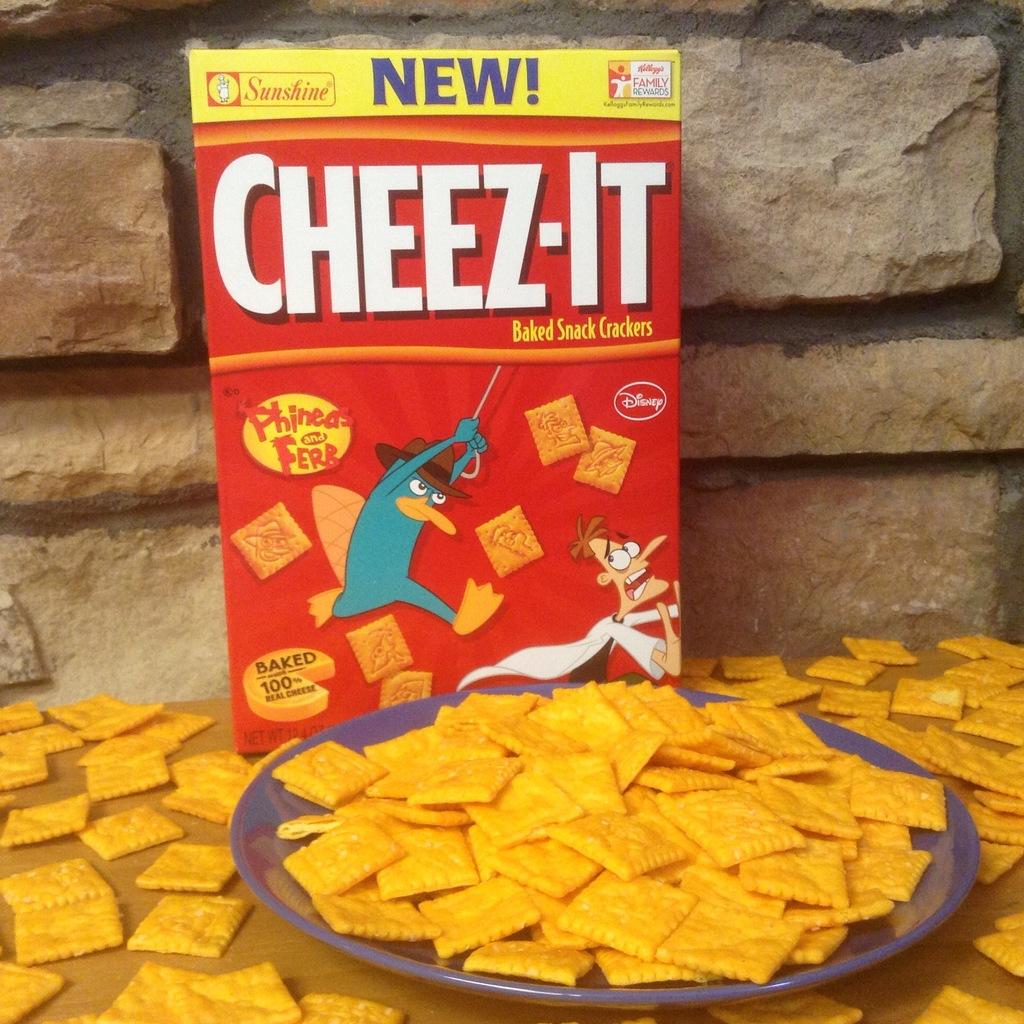What is this cracker's name?
Ensure brevity in your answer.  Cheez-it. 